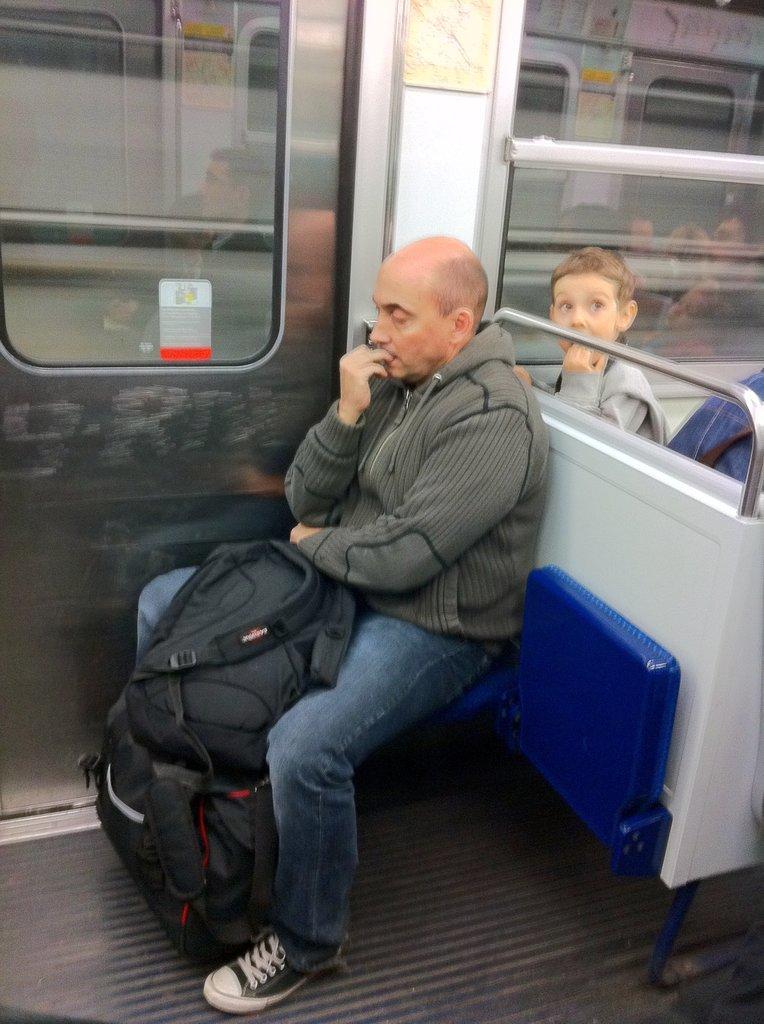Please provide a concise description of this image. In this image I can see a person sitting on the blue color seat. He is wearing ash jacket and jeans and holding black color bags. Back Side I can see a glass door. 